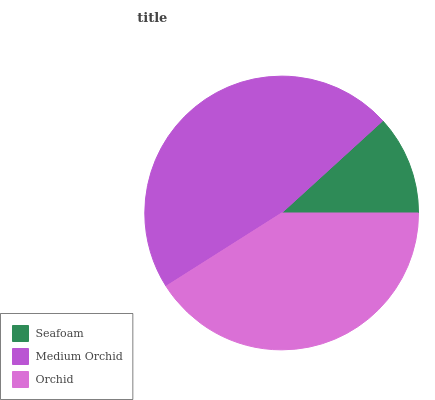Is Seafoam the minimum?
Answer yes or no. Yes. Is Medium Orchid the maximum?
Answer yes or no. Yes. Is Orchid the minimum?
Answer yes or no. No. Is Orchid the maximum?
Answer yes or no. No. Is Medium Orchid greater than Orchid?
Answer yes or no. Yes. Is Orchid less than Medium Orchid?
Answer yes or no. Yes. Is Orchid greater than Medium Orchid?
Answer yes or no. No. Is Medium Orchid less than Orchid?
Answer yes or no. No. Is Orchid the high median?
Answer yes or no. Yes. Is Orchid the low median?
Answer yes or no. Yes. Is Seafoam the high median?
Answer yes or no. No. Is Medium Orchid the low median?
Answer yes or no. No. 